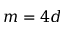<formula> <loc_0><loc_0><loc_500><loc_500>m = 4 d</formula> 